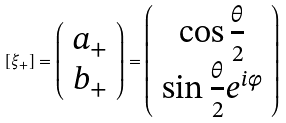<formula> <loc_0><loc_0><loc_500><loc_500>[ \xi _ { + } ] = \left ( \begin{array} { c } a _ { + } \\ b _ { + } \end{array} \right ) = \left ( \begin{array} { c } \cos \frac { \theta } { 2 } \\ \sin \frac { \theta } { 2 } e ^ { i \varphi } \end{array} \right ) \text { }</formula> 